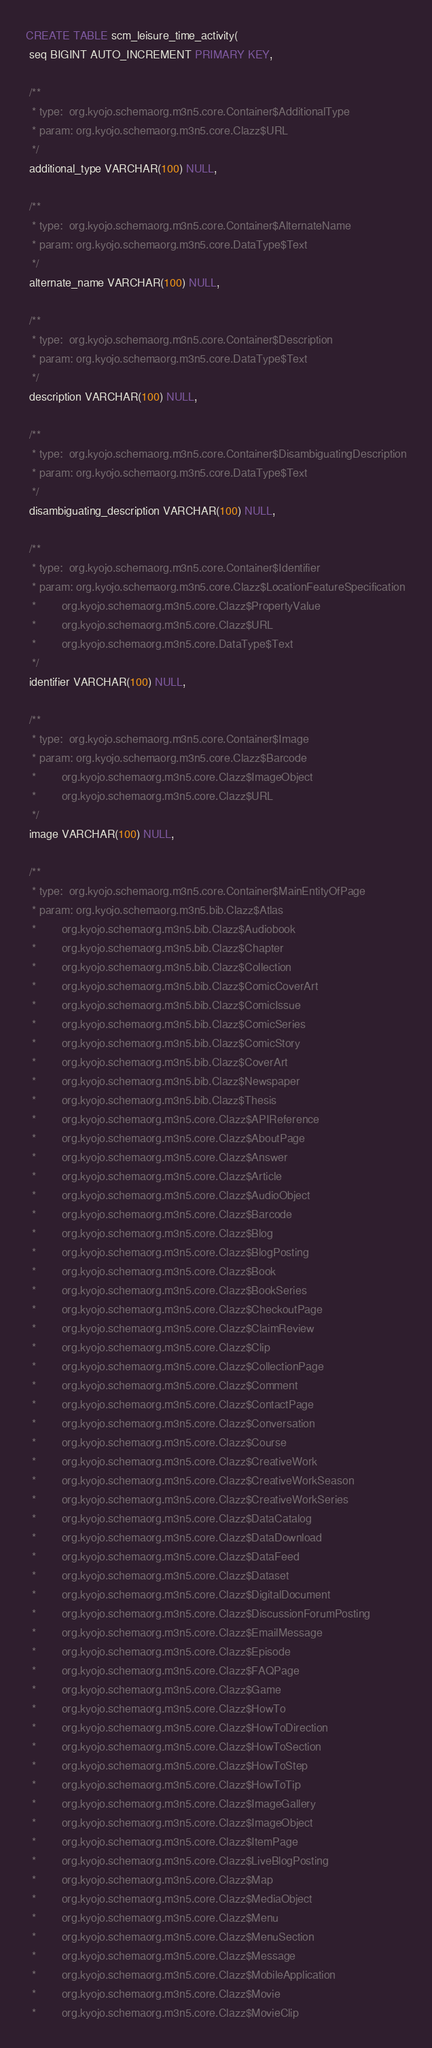Convert code to text. <code><loc_0><loc_0><loc_500><loc_500><_SQL_>CREATE TABLE scm_leisure_time_activity(
 seq BIGINT AUTO_INCREMENT PRIMARY KEY,

 /**
  * type:  org.kyojo.schemaorg.m3n5.core.Container$AdditionalType
  * param: org.kyojo.schemaorg.m3n5.core.Clazz$URL
  */
 additional_type VARCHAR(100) NULL,

 /**
  * type:  org.kyojo.schemaorg.m3n5.core.Container$AlternateName
  * param: org.kyojo.schemaorg.m3n5.core.DataType$Text
  */
 alternate_name VARCHAR(100) NULL,

 /**
  * type:  org.kyojo.schemaorg.m3n5.core.Container$Description
  * param: org.kyojo.schemaorg.m3n5.core.DataType$Text
  */
 description VARCHAR(100) NULL,

 /**
  * type:  org.kyojo.schemaorg.m3n5.core.Container$DisambiguatingDescription
  * param: org.kyojo.schemaorg.m3n5.core.DataType$Text
  */
 disambiguating_description VARCHAR(100) NULL,

 /**
  * type:  org.kyojo.schemaorg.m3n5.core.Container$Identifier
  * param: org.kyojo.schemaorg.m3n5.core.Clazz$LocationFeatureSpecification
  *        org.kyojo.schemaorg.m3n5.core.Clazz$PropertyValue
  *        org.kyojo.schemaorg.m3n5.core.Clazz$URL
  *        org.kyojo.schemaorg.m3n5.core.DataType$Text
  */
 identifier VARCHAR(100) NULL,

 /**
  * type:  org.kyojo.schemaorg.m3n5.core.Container$Image
  * param: org.kyojo.schemaorg.m3n5.core.Clazz$Barcode
  *        org.kyojo.schemaorg.m3n5.core.Clazz$ImageObject
  *        org.kyojo.schemaorg.m3n5.core.Clazz$URL
  */
 image VARCHAR(100) NULL,

 /**
  * type:  org.kyojo.schemaorg.m3n5.core.Container$MainEntityOfPage
  * param: org.kyojo.schemaorg.m3n5.bib.Clazz$Atlas
  *        org.kyojo.schemaorg.m3n5.bib.Clazz$Audiobook
  *        org.kyojo.schemaorg.m3n5.bib.Clazz$Chapter
  *        org.kyojo.schemaorg.m3n5.bib.Clazz$Collection
  *        org.kyojo.schemaorg.m3n5.bib.Clazz$ComicCoverArt
  *        org.kyojo.schemaorg.m3n5.bib.Clazz$ComicIssue
  *        org.kyojo.schemaorg.m3n5.bib.Clazz$ComicSeries
  *        org.kyojo.schemaorg.m3n5.bib.Clazz$ComicStory
  *        org.kyojo.schemaorg.m3n5.bib.Clazz$CoverArt
  *        org.kyojo.schemaorg.m3n5.bib.Clazz$Newspaper
  *        org.kyojo.schemaorg.m3n5.bib.Clazz$Thesis
  *        org.kyojo.schemaorg.m3n5.core.Clazz$APIReference
  *        org.kyojo.schemaorg.m3n5.core.Clazz$AboutPage
  *        org.kyojo.schemaorg.m3n5.core.Clazz$Answer
  *        org.kyojo.schemaorg.m3n5.core.Clazz$Article
  *        org.kyojo.schemaorg.m3n5.core.Clazz$AudioObject
  *        org.kyojo.schemaorg.m3n5.core.Clazz$Barcode
  *        org.kyojo.schemaorg.m3n5.core.Clazz$Blog
  *        org.kyojo.schemaorg.m3n5.core.Clazz$BlogPosting
  *        org.kyojo.schemaorg.m3n5.core.Clazz$Book
  *        org.kyojo.schemaorg.m3n5.core.Clazz$BookSeries
  *        org.kyojo.schemaorg.m3n5.core.Clazz$CheckoutPage
  *        org.kyojo.schemaorg.m3n5.core.Clazz$ClaimReview
  *        org.kyojo.schemaorg.m3n5.core.Clazz$Clip
  *        org.kyojo.schemaorg.m3n5.core.Clazz$CollectionPage
  *        org.kyojo.schemaorg.m3n5.core.Clazz$Comment
  *        org.kyojo.schemaorg.m3n5.core.Clazz$ContactPage
  *        org.kyojo.schemaorg.m3n5.core.Clazz$Conversation
  *        org.kyojo.schemaorg.m3n5.core.Clazz$Course
  *        org.kyojo.schemaorg.m3n5.core.Clazz$CreativeWork
  *        org.kyojo.schemaorg.m3n5.core.Clazz$CreativeWorkSeason
  *        org.kyojo.schemaorg.m3n5.core.Clazz$CreativeWorkSeries
  *        org.kyojo.schemaorg.m3n5.core.Clazz$DataCatalog
  *        org.kyojo.schemaorg.m3n5.core.Clazz$DataDownload
  *        org.kyojo.schemaorg.m3n5.core.Clazz$DataFeed
  *        org.kyojo.schemaorg.m3n5.core.Clazz$Dataset
  *        org.kyojo.schemaorg.m3n5.core.Clazz$DigitalDocument
  *        org.kyojo.schemaorg.m3n5.core.Clazz$DiscussionForumPosting
  *        org.kyojo.schemaorg.m3n5.core.Clazz$EmailMessage
  *        org.kyojo.schemaorg.m3n5.core.Clazz$Episode
  *        org.kyojo.schemaorg.m3n5.core.Clazz$FAQPage
  *        org.kyojo.schemaorg.m3n5.core.Clazz$Game
  *        org.kyojo.schemaorg.m3n5.core.Clazz$HowTo
  *        org.kyojo.schemaorg.m3n5.core.Clazz$HowToDirection
  *        org.kyojo.schemaorg.m3n5.core.Clazz$HowToSection
  *        org.kyojo.schemaorg.m3n5.core.Clazz$HowToStep
  *        org.kyojo.schemaorg.m3n5.core.Clazz$HowToTip
  *        org.kyojo.schemaorg.m3n5.core.Clazz$ImageGallery
  *        org.kyojo.schemaorg.m3n5.core.Clazz$ImageObject
  *        org.kyojo.schemaorg.m3n5.core.Clazz$ItemPage
  *        org.kyojo.schemaorg.m3n5.core.Clazz$LiveBlogPosting
  *        org.kyojo.schemaorg.m3n5.core.Clazz$Map
  *        org.kyojo.schemaorg.m3n5.core.Clazz$MediaObject
  *        org.kyojo.schemaorg.m3n5.core.Clazz$Menu
  *        org.kyojo.schemaorg.m3n5.core.Clazz$MenuSection
  *        org.kyojo.schemaorg.m3n5.core.Clazz$Message
  *        org.kyojo.schemaorg.m3n5.core.Clazz$MobileApplication
  *        org.kyojo.schemaorg.m3n5.core.Clazz$Movie
  *        org.kyojo.schemaorg.m3n5.core.Clazz$MovieClip</code> 